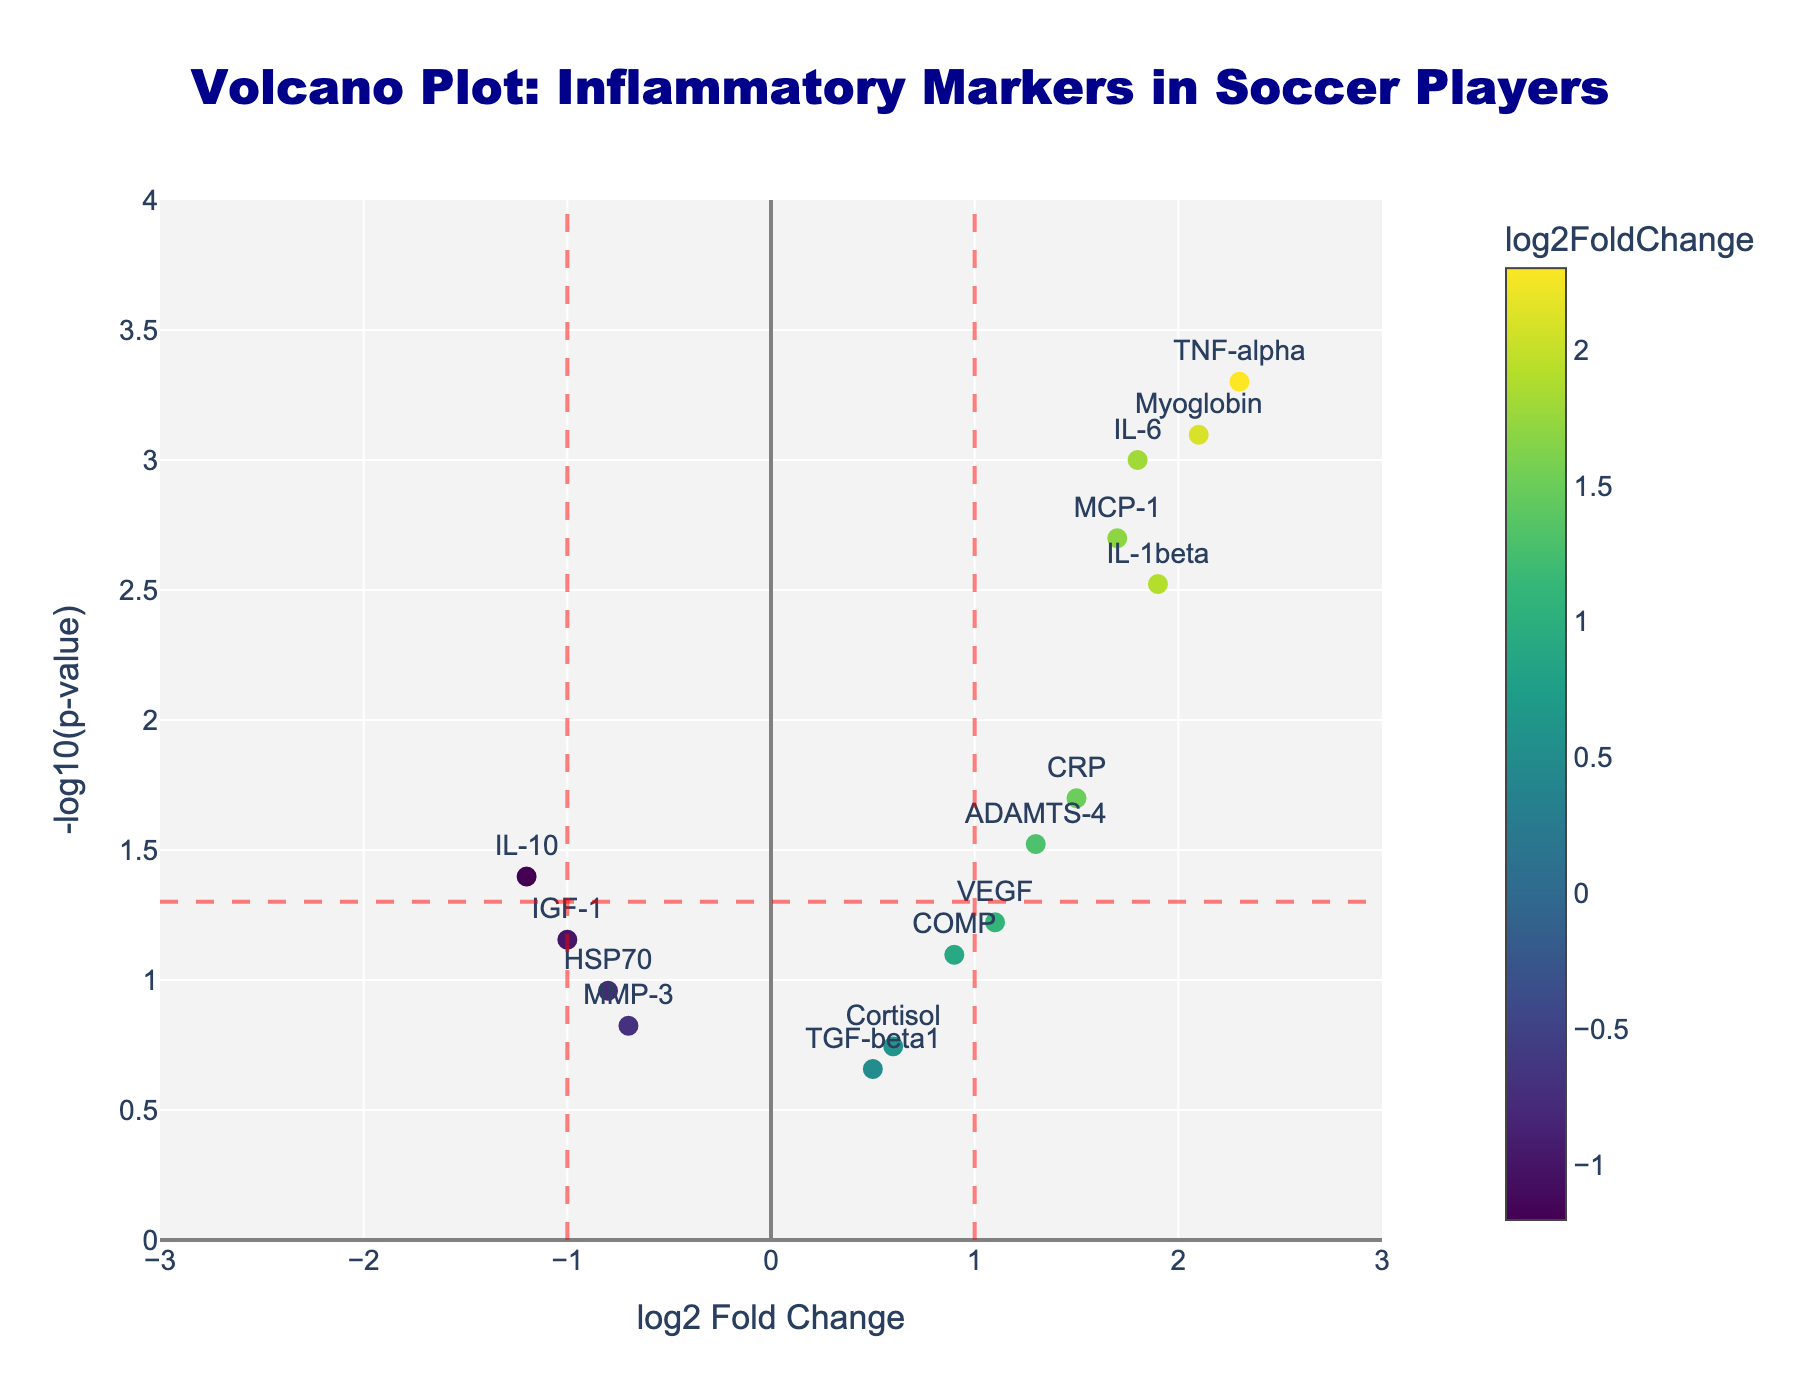What is the title of the plot? The title of the plot is displayed at the top and it reads "Volcano Plot: Inflammatory Markers in Soccer Players".
Answer: Volcano Plot: Inflammatory Markers in Soccer Players What do the x-axis and y-axis represent? The x-axis represents the "log2 Fold Change" and the y-axis represents the "-log10(p-value)". These axes provide a scatter plot of fold changes in gene expression against their statistical significance.
Answer: log2 Fold Change and -log10(p-value) How many markers have a log2 Fold Change greater than 1? To answer this, count the number of markers to the right of the vertical red dashed line at x=1. These markers are TNF-alpha, IL-1beta, IL-6, ADAMTS-4, Myoglobin, and MCP-1.
Answer: 6 Which marker has the highest log2 Fold Change and what is its value? The marker with the highest log2 Fold Change is TNF-alpha, as it is positioned farthest to the right on the x-axis. Its value is approximately 2.3.
Answer: TNF-alpha, 2.3 Which marker is the most statistically significant and what is its p-value? The marker with the smallest p-value will be highest on the y-axis since -log10(p-value) is larger. TNF-alpha is the highest, with a p-value of 0.0005.
Answer: TNF-alpha, 0.0005 Are there any markers with a negative log2 Fold Change and statistically significant p-value? Yes, identify markers to the left of the vertical red dashed lines at x=-1 and above the horizontal red dashed line at y=-log10(0.05). The relevant marker is IL-10.
Answer: IL-10 Which markers do not meet statistical significance criteria (p-value > 0.05)? Markers below the horizontal red dashed line at y=-log10(0.05) are not statistically significant. These are MMP-3, COMP, TGF-beta1, VEGF, HSP70, Cortisol, and IGF-1.
Answer: MMP-3, COMP, TGF-beta1, VEGF, HSP70, Cortisol, IGF-1 Compare IL-1beta and ADAMTS-4 in terms of log2 Fold Change and statistical significance. IL-1beta has a log2 Fold Change of 1.9 and p-value of 0.003, while ADAMTS-4 has a log2 Fold Change of 1.3 and p-value of 0.03. IL-1beta is higher in both log2 Fold Change and statistical significance (-log10(p-value)).
Answer: IL-1beta is higher in both What is the range of the y-axis values? The y-axis range is determined by the minimum and maximum values of -log10(p-value). From the plot, the range is from 0 to approximately 4 based on the grid.
Answer: 0 to 4 Name a marker with a log2 Fold Change close to zero but has a p-value near the significance threshold. VEGF has a log2 Fold Change of 1.1, which is relatively close to zero, and a p-value of 0.06, which is close to the significance threshold.
Answer: VEGF 